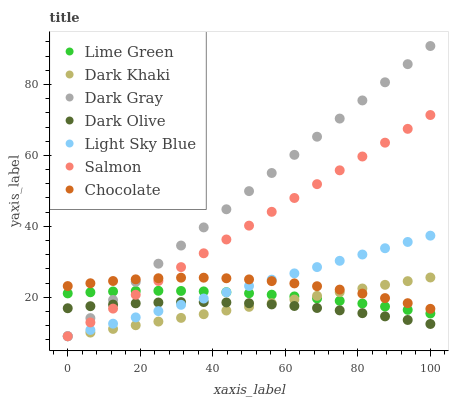Does Dark Olive have the minimum area under the curve?
Answer yes or no. Yes. Does Dark Gray have the maximum area under the curve?
Answer yes or no. Yes. Does Salmon have the minimum area under the curve?
Answer yes or no. No. Does Salmon have the maximum area under the curve?
Answer yes or no. No. Is Dark Khaki the smoothest?
Answer yes or no. Yes. Is Chocolate the roughest?
Answer yes or no. Yes. Is Dark Olive the smoothest?
Answer yes or no. No. Is Dark Olive the roughest?
Answer yes or no. No. Does Dark Gray have the lowest value?
Answer yes or no. Yes. Does Dark Olive have the lowest value?
Answer yes or no. No. Does Dark Gray have the highest value?
Answer yes or no. Yes. Does Salmon have the highest value?
Answer yes or no. No. Is Dark Olive less than Lime Green?
Answer yes or no. Yes. Is Chocolate greater than Dark Olive?
Answer yes or no. Yes. Does Light Sky Blue intersect Dark Khaki?
Answer yes or no. Yes. Is Light Sky Blue less than Dark Khaki?
Answer yes or no. No. Is Light Sky Blue greater than Dark Khaki?
Answer yes or no. No. Does Dark Olive intersect Lime Green?
Answer yes or no. No. 